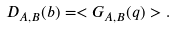Convert formula to latex. <formula><loc_0><loc_0><loc_500><loc_500>D _ { A , B } ( b ) = < G _ { A , B } ( q ) > .</formula> 